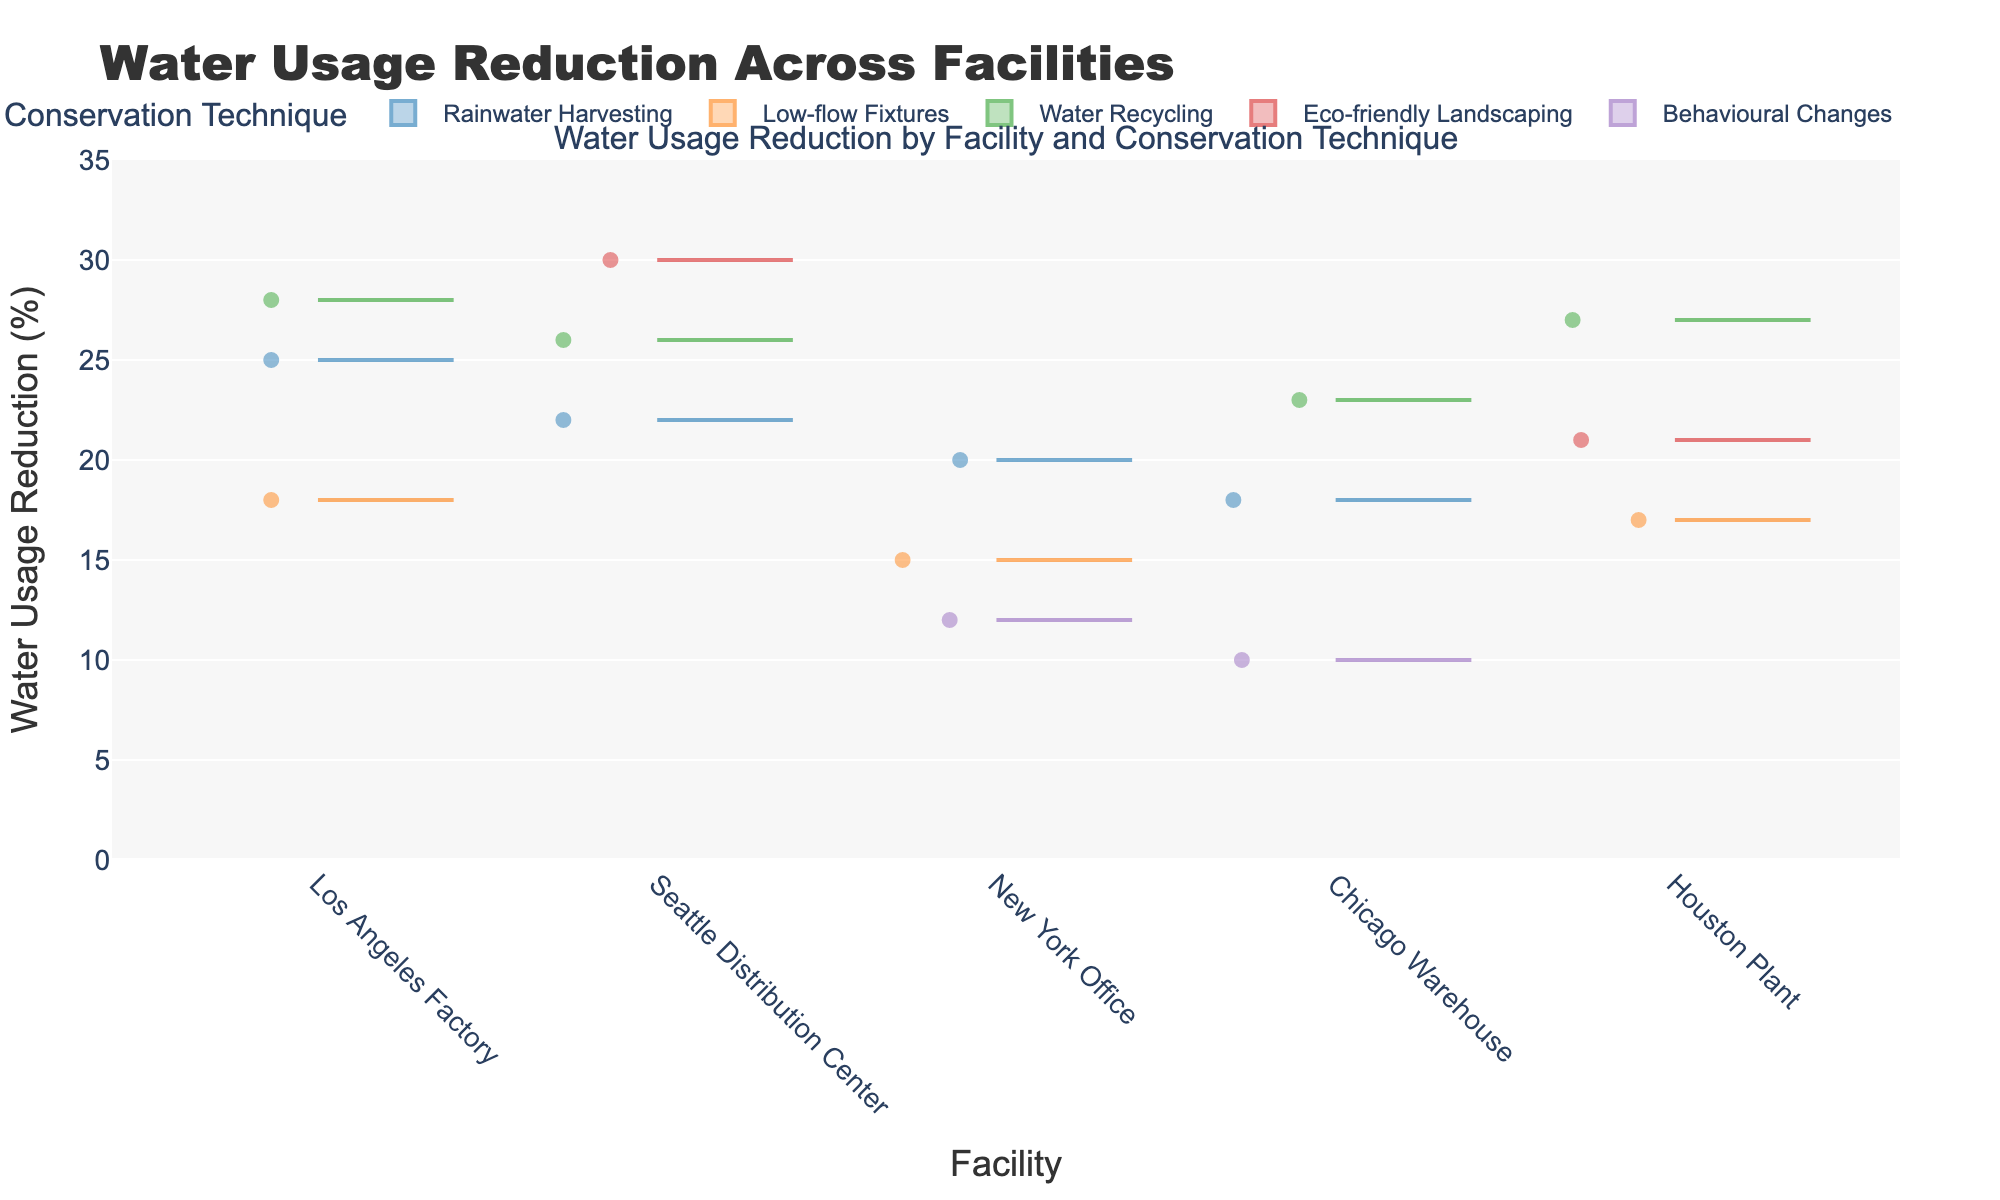What is the title of the plot? The title of the plot is usually placed at the top and describes the main subject of the figure. In this case, it is "Water Usage Reduction by Facility and Conservation Technique."
Answer: Water Usage Reduction by Facility and Conservation Technique Which conservation technique has the highest median water usage reduction? The median value is represented by the line within each box plot. By observing the violin chart, the technique with the highest median value can be identified.
Answer: Eco-friendly Landscaping Which facility shows the widest range of water usage reduction for techniques implemented? The range of water usage reduction can be determined by looking at the span of the violin plot of each facility. The facility with the widest span from minimum to maximum values has the widest range.
Answer: Los Angeles Factory Comparing Low-flow Fixtures and Rainwater Harvesting, which technique has a higher variability in water usage reduction across facilities? Variability can be assessed by looking at how wide each violin plot spreads. The technique with a more spread-out violin plot indicates higher variability.
Answer: Rainwater Harvesting What is the approximate water usage reduction median for Water Recycling across all facilities? The median value is represented by the line inside the box plot which overlays the violin plot. By looking at the median line within the Water Recycling plots, the approximate median value can be determined.
Answer: 26% How does the water usage reduction for Behavioural Changes in the Chicago Warehouse compare to that in the New York Office? The values for Behavioural Changes can be compared by looking at the position of the median lines in the violin plots for each facility.
Answer: Lower in Chicago Warehouse than New York Office Considering Rainwater Harvesting, which facility achieved the highest water usage reduction? By checking the upper extremes of the violin plot for Rainwater Harvesting in each facility, the one with the highest value will indicate the facility with the highest reduction.
Answer: Los Angeles Factory When considering Low-flow Fixtures across all facilities, what is the approximate average reduction in water usage? Observing the average would require assessing the middle of the data range via the box plot's mean line. For a more precise answer, one would consider the mid-point values of each facility and estimate an average.
Answer: Approximately 16.7% Which facility has the lowest overall performance in water usage reduction regardless of the conservation technique used? The lowest overall performance can be identified by looking at the lower extremes of all violin plots and box plots across all techniques for each facility.
Answer: Chicago Warehouse Does the New York Office show more consistency in water usage reduction for any specific conservation technique compared to others? Consistency is represented by a narrower range and a tightly bound box within the violin plot. By observing the width of the violin plots for New York Office under each technique, we can identify the most consistent one.
Answer: Yes, Low-flow Fixtures 